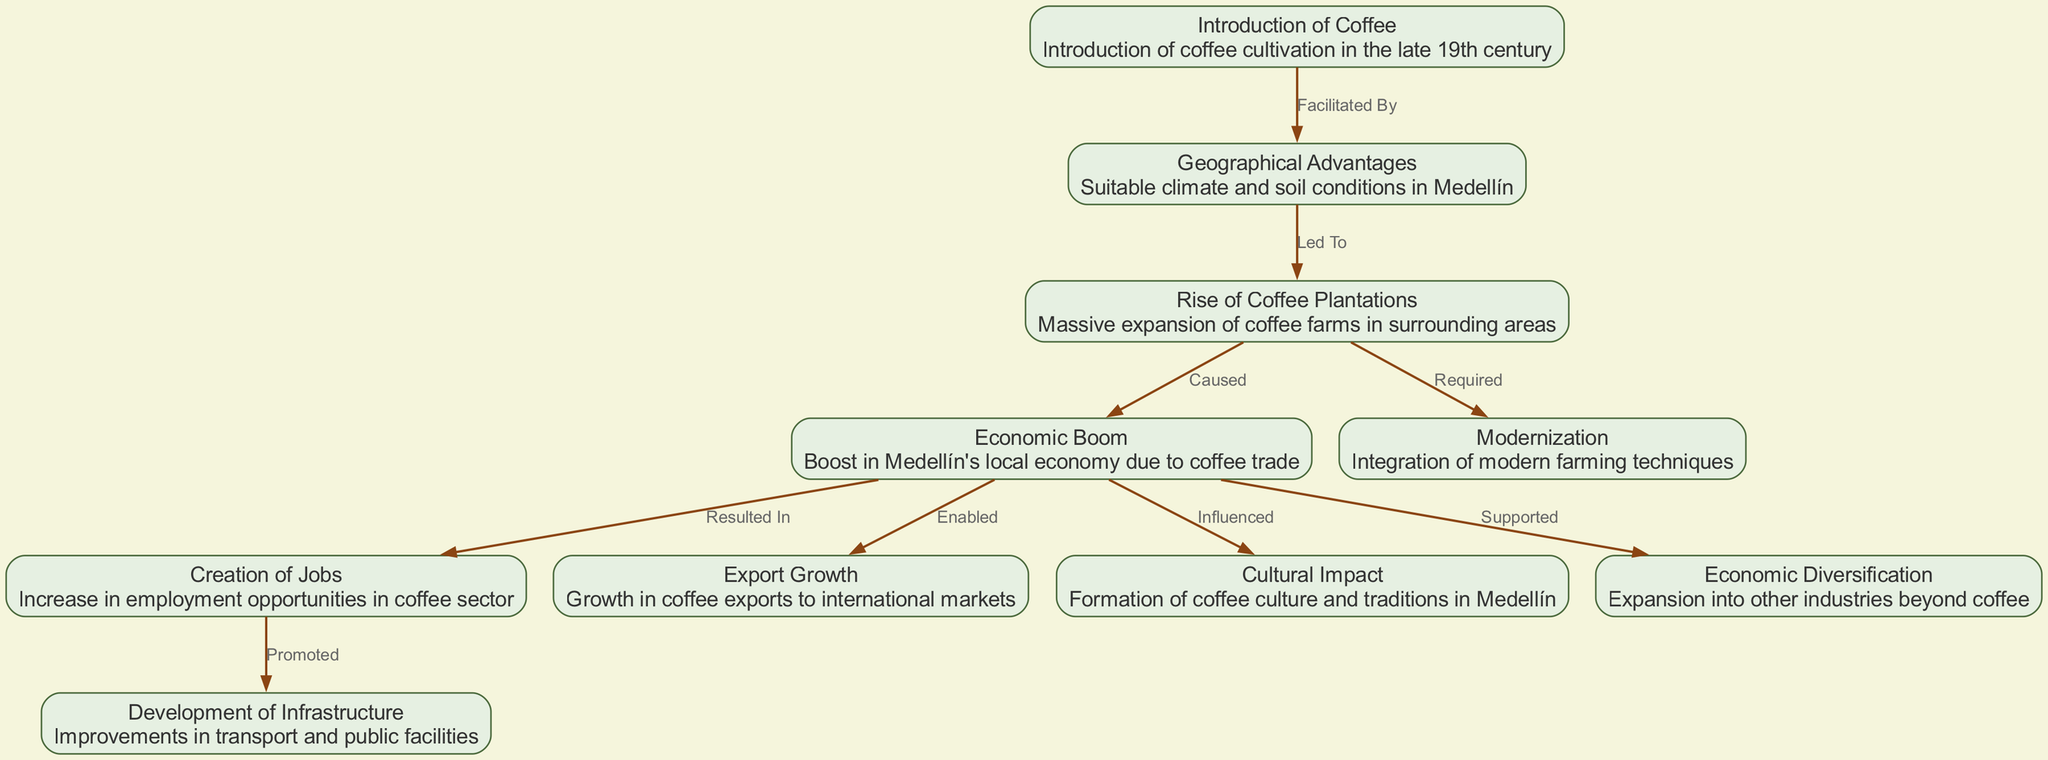What introduced coffee cultivation to Medellín? The diagram shows "Introduction of Coffee" as the first node, which states that coffee cultivation was introduced in the late 19th century. This implies that this is the beginning of coffee cultivation's impact on the economy of Medellín.
Answer: Introduction of Coffee What facilitated the introduction of coffee in Medellín? The edge labeled "Facilitated By" connects "Introduction of Coffee" to "Geographical Advantages". This indicates that geographical factors were crucial in enabling the coffee introduction in the region.
Answer: Geographical Advantages How many edges are in the diagram? By counting the connections (edges) depicted in the diagram, we find that there are a total of 9 edges connecting various nodes based on their relationships.
Answer: 9 What resulted from the economic boom due to coffee trade? The edge reads "Resulted In" linking "Economic Boom" to "Creation of Jobs", indicating that the economic success led to increased employment opportunities in the coffee sector.
Answer: Creation of Jobs What is one cultural impact of coffee cultivation in Medellín? According to the edge labeled "Influenced" from the "Economic Boom" node to the "Cultural Impact" node, the economic benefits also affected local culture, highlighting that coffee cultivation contributed significantly to the formation of coffee culture and traditions.
Answer: Cultural Impact Which node specifies the need for modern farming techniques? The edge "Required" connects "Rise of Coffee Plantations" to "Modernization". This indicates that the expansion of coffee farms necessitated the adoption of modern farming methods.
Answer: Modernization What supported the diversification of Medellín's economy? The edge labeled "Supported" connects "Economic Boom" to "Economic Diversification", showing that the benefits and growth from coffee cultivation allowed Medellín to expand into other industries beyond coffee.
Answer: Economic Diversification Which node represents the international market expansion for coffee? The edge "Enabled" from "Economic Boom" to "Export Growth" indicates that the economic advancements allowed Medellín to increase coffee exports to international markets.
Answer: Export Growth What caused the economic boom in Medellín? The edge labeled "Caused" linking "Rise of Coffee Plantations" to "Economic Boom" explicitly states that the significant growth in coffee farms directly led to economic prosperity in the city.
Answer: Economic Boom 